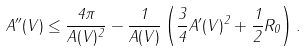<formula> <loc_0><loc_0><loc_500><loc_500>A ^ { \prime \prime } ( V ) \leq \frac { 4 \pi } { A ( V ) ^ { 2 } } - \frac { 1 } { A ( V ) } \left ( \frac { 3 } { 4 } A ^ { \prime } ( V ) ^ { 2 } + \frac { 1 } { 2 } R _ { 0 } \right ) .</formula> 